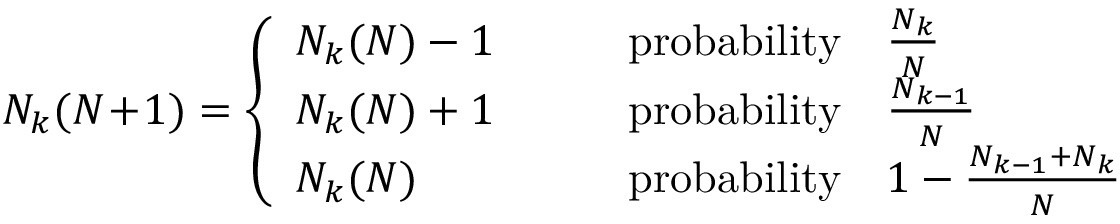<formula> <loc_0><loc_0><loc_500><loc_500>N _ { k } ( N \, + \, 1 ) = \left \{ \begin{array} { l l } { N _ { k } ( N ) - 1 } & { \quad p r o b a b i l i t y \quad \frac { N _ { k } } { N } } \\ { N _ { k } ( N ) + 1 } & { \quad p r o b a b i l i t y \quad \frac { N _ { k - 1 } } { N } } \\ { N _ { k } ( N ) } & { \quad p r o b a b i l i t y \quad 1 - \frac { N _ { k - 1 } + N _ { k } } { N } } \end{array}</formula> 